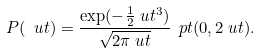<formula> <loc_0><loc_0><loc_500><loc_500>P ( \ u t ) & = \frac { \exp ( - \frac { 1 } { 2 } \ u t ^ { 3 } ) } { \sqrt { 2 \pi \ u t } } \, \ p t ( 0 , 2 \ u t ) .</formula> 